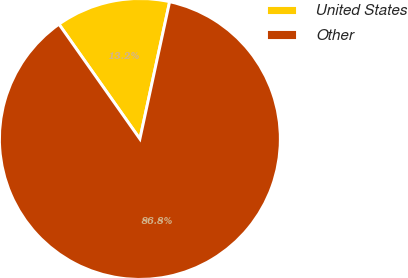<chart> <loc_0><loc_0><loc_500><loc_500><pie_chart><fcel>United States<fcel>Other<nl><fcel>13.17%<fcel>86.83%<nl></chart> 